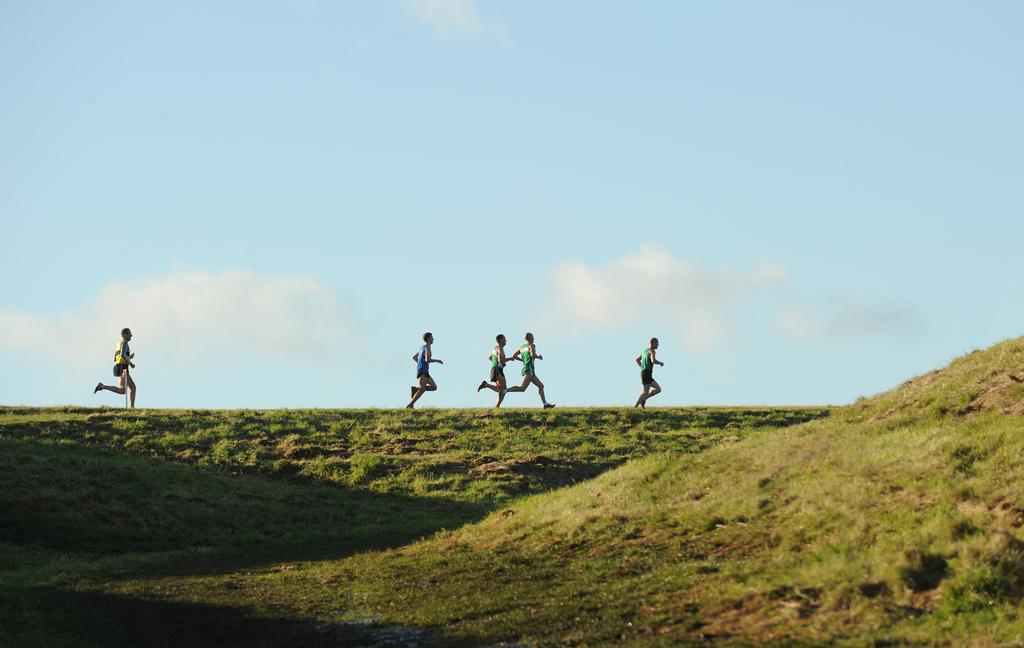What is the main subject of the image? The main subject of the image is people. Where are the people located in the image? The people are in the center of the image. What type of environment are the people in? The people are on a grassland. What are the people doing in the image? The people appear to be running. What else can be seen in the image besides the people? There is another man on the left side of the image, and the sky is visible. Can you tell me how many goldfish are swimming in the pond in the image? There is no pond or goldfish present in the image; it features people on a grassland. 